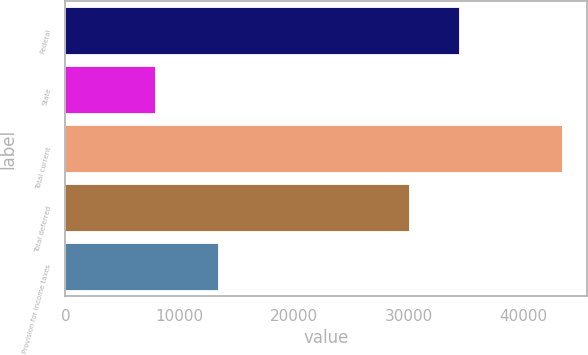<chart> <loc_0><loc_0><loc_500><loc_500><bar_chart><fcel>Federal<fcel>State<fcel>Total current<fcel>Total deferred<fcel>Provision for income taxes<nl><fcel>34387<fcel>7850<fcel>43399<fcel>30071<fcel>13328<nl></chart> 